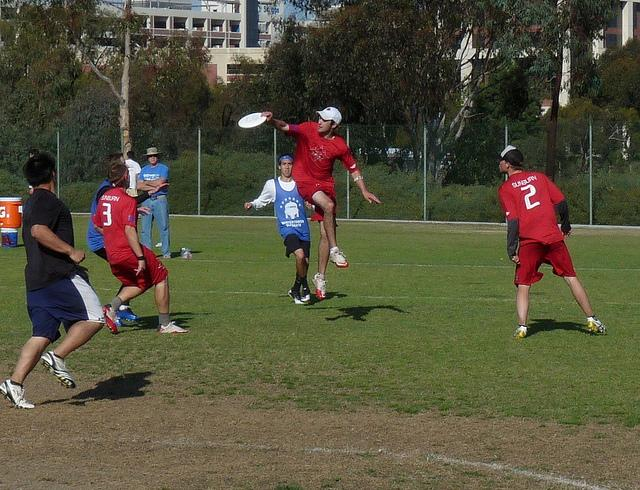What company has trademarked the popular name of this toy? Please explain your reasoning. wham-o. Whamo is a game that involves frisbees. 